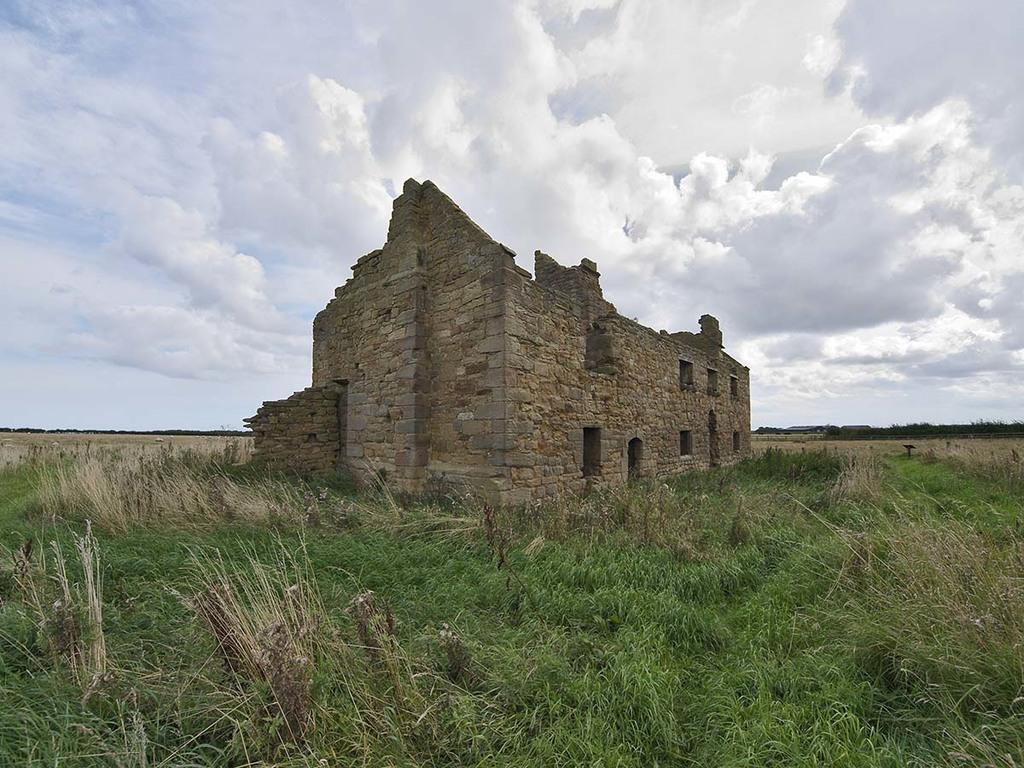Please provide a concise description of this image. In this image there is a field, in the middle of the field there is a fort, in the background there is cloudy sky. 